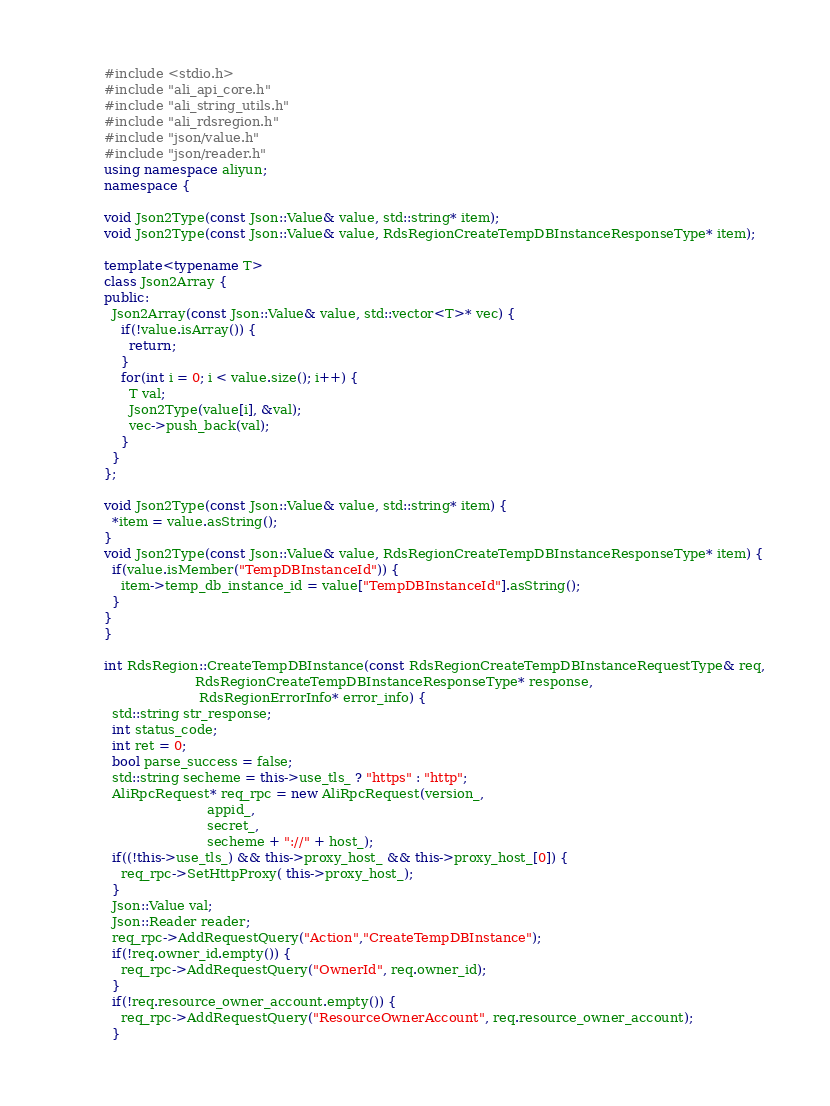<code> <loc_0><loc_0><loc_500><loc_500><_C++_>#include <stdio.h>
#include "ali_api_core.h"
#include "ali_string_utils.h"
#include "ali_rdsregion.h"
#include "json/value.h"
#include "json/reader.h"
using namespace aliyun;
namespace {

void Json2Type(const Json::Value& value, std::string* item);
void Json2Type(const Json::Value& value, RdsRegionCreateTempDBInstanceResponseType* item);

template<typename T>
class Json2Array {
public:
  Json2Array(const Json::Value& value, std::vector<T>* vec) {
    if(!value.isArray()) {
      return;
    }
    for(int i = 0; i < value.size(); i++) {
      T val;
      Json2Type(value[i], &val);
      vec->push_back(val);
    }
  }
};

void Json2Type(const Json::Value& value, std::string* item) {
  *item = value.asString();
}
void Json2Type(const Json::Value& value, RdsRegionCreateTempDBInstanceResponseType* item) {
  if(value.isMember("TempDBInstanceId")) {
    item->temp_db_instance_id = value["TempDBInstanceId"].asString();
  }
}
}

int RdsRegion::CreateTempDBInstance(const RdsRegionCreateTempDBInstanceRequestType& req,
                      RdsRegionCreateTempDBInstanceResponseType* response,
                       RdsRegionErrorInfo* error_info) {
  std::string str_response;
  int status_code;
  int ret = 0;
  bool parse_success = false;
  std::string secheme = this->use_tls_ ? "https" : "http";
  AliRpcRequest* req_rpc = new AliRpcRequest(version_,
                         appid_,
                         secret_,
                         secheme + "://" + host_);
  if((!this->use_tls_) && this->proxy_host_ && this->proxy_host_[0]) {
    req_rpc->SetHttpProxy( this->proxy_host_);
  }
  Json::Value val;
  Json::Reader reader;
  req_rpc->AddRequestQuery("Action","CreateTempDBInstance");
  if(!req.owner_id.empty()) {
    req_rpc->AddRequestQuery("OwnerId", req.owner_id);
  }
  if(!req.resource_owner_account.empty()) {
    req_rpc->AddRequestQuery("ResourceOwnerAccount", req.resource_owner_account);
  }</code> 